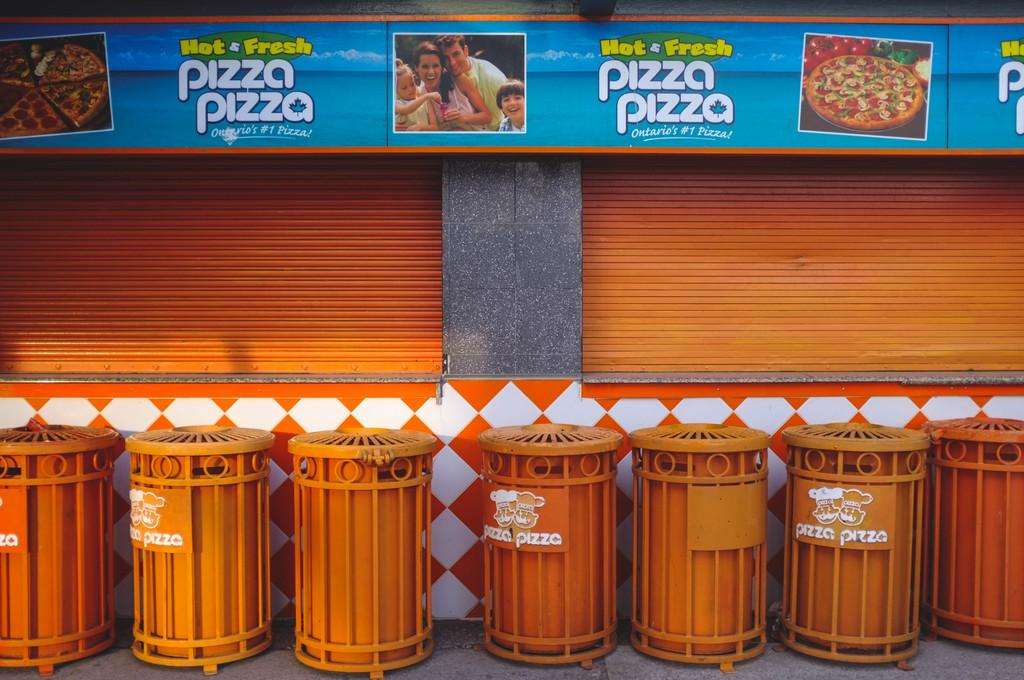<image>
Present a compact description of the photo's key features. Orange bins in front of a wall which says Pizza Pizza. 